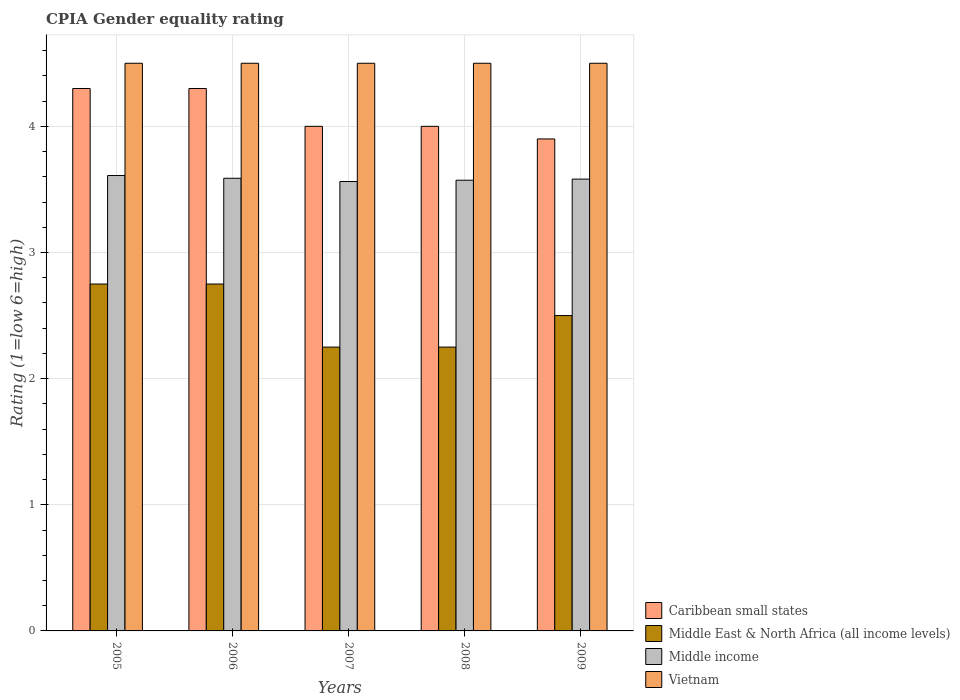How many different coloured bars are there?
Make the answer very short. 4. How many groups of bars are there?
Make the answer very short. 5. Are the number of bars on each tick of the X-axis equal?
Provide a short and direct response. Yes. How many bars are there on the 2nd tick from the left?
Provide a short and direct response. 4. How many bars are there on the 4th tick from the right?
Offer a very short reply. 4. What is the label of the 3rd group of bars from the left?
Offer a terse response. 2007. What is the CPIA rating in Caribbean small states in 2005?
Offer a very short reply. 4.3. Across all years, what is the maximum CPIA rating in Middle income?
Keep it short and to the point. 3.61. Across all years, what is the minimum CPIA rating in Middle East & North Africa (all income levels)?
Keep it short and to the point. 2.25. In which year was the CPIA rating in Vietnam maximum?
Your answer should be compact. 2005. In which year was the CPIA rating in Vietnam minimum?
Your answer should be very brief. 2005. What is the difference between the CPIA rating in Caribbean small states in 2007 and that in 2009?
Your response must be concise. 0.1. What is the difference between the CPIA rating in Caribbean small states in 2005 and the CPIA rating in Middle East & North Africa (all income levels) in 2009?
Ensure brevity in your answer.  1.8. What is the average CPIA rating in Middle East & North Africa (all income levels) per year?
Offer a terse response. 2.5. In the year 2006, what is the difference between the CPIA rating in Caribbean small states and CPIA rating in Vietnam?
Provide a succinct answer. -0.2. In how many years, is the CPIA rating in Middle income greater than 0.4?
Give a very brief answer. 5. What is the ratio of the CPIA rating in Caribbean small states in 2006 to that in 2009?
Your answer should be very brief. 1.1. What is the difference between the highest and the second highest CPIA rating in Middle East & North Africa (all income levels)?
Your response must be concise. 0. What is the difference between the highest and the lowest CPIA rating in Middle income?
Ensure brevity in your answer.  0.05. Is the sum of the CPIA rating in Middle East & North Africa (all income levels) in 2005 and 2009 greater than the maximum CPIA rating in Vietnam across all years?
Your answer should be very brief. Yes. Is it the case that in every year, the sum of the CPIA rating in Middle income and CPIA rating in Vietnam is greater than the sum of CPIA rating in Caribbean small states and CPIA rating in Middle East & North Africa (all income levels)?
Offer a terse response. No. What does the 1st bar from the left in 2009 represents?
Offer a very short reply. Caribbean small states. What does the 1st bar from the right in 2009 represents?
Offer a terse response. Vietnam. How many years are there in the graph?
Offer a terse response. 5. Does the graph contain grids?
Your answer should be very brief. Yes. How are the legend labels stacked?
Offer a terse response. Vertical. What is the title of the graph?
Provide a succinct answer. CPIA Gender equality rating. What is the Rating (1=low 6=high) of Middle East & North Africa (all income levels) in 2005?
Offer a very short reply. 2.75. What is the Rating (1=low 6=high) in Middle income in 2005?
Provide a succinct answer. 3.61. What is the Rating (1=low 6=high) in Middle East & North Africa (all income levels) in 2006?
Make the answer very short. 2.75. What is the Rating (1=low 6=high) of Middle income in 2006?
Ensure brevity in your answer.  3.59. What is the Rating (1=low 6=high) of Caribbean small states in 2007?
Provide a short and direct response. 4. What is the Rating (1=low 6=high) of Middle East & North Africa (all income levels) in 2007?
Your response must be concise. 2.25. What is the Rating (1=low 6=high) in Middle income in 2007?
Make the answer very short. 3.56. What is the Rating (1=low 6=high) in Vietnam in 2007?
Your answer should be compact. 4.5. What is the Rating (1=low 6=high) of Middle East & North Africa (all income levels) in 2008?
Ensure brevity in your answer.  2.25. What is the Rating (1=low 6=high) in Middle income in 2008?
Provide a succinct answer. 3.57. What is the Rating (1=low 6=high) in Vietnam in 2008?
Your answer should be compact. 4.5. What is the Rating (1=low 6=high) of Middle income in 2009?
Provide a short and direct response. 3.58. Across all years, what is the maximum Rating (1=low 6=high) of Caribbean small states?
Give a very brief answer. 4.3. Across all years, what is the maximum Rating (1=low 6=high) in Middle East & North Africa (all income levels)?
Provide a succinct answer. 2.75. Across all years, what is the maximum Rating (1=low 6=high) in Middle income?
Your answer should be compact. 3.61. Across all years, what is the maximum Rating (1=low 6=high) in Vietnam?
Your answer should be compact. 4.5. Across all years, what is the minimum Rating (1=low 6=high) of Caribbean small states?
Provide a short and direct response. 3.9. Across all years, what is the minimum Rating (1=low 6=high) of Middle East & North Africa (all income levels)?
Your answer should be very brief. 2.25. Across all years, what is the minimum Rating (1=low 6=high) of Middle income?
Your response must be concise. 3.56. Across all years, what is the minimum Rating (1=low 6=high) of Vietnam?
Make the answer very short. 4.5. What is the total Rating (1=low 6=high) in Caribbean small states in the graph?
Provide a succinct answer. 20.5. What is the total Rating (1=low 6=high) in Middle East & North Africa (all income levels) in the graph?
Your answer should be very brief. 12.5. What is the total Rating (1=low 6=high) in Middle income in the graph?
Keep it short and to the point. 17.92. What is the total Rating (1=low 6=high) in Vietnam in the graph?
Offer a very short reply. 22.5. What is the difference between the Rating (1=low 6=high) in Caribbean small states in 2005 and that in 2006?
Ensure brevity in your answer.  0. What is the difference between the Rating (1=low 6=high) of Middle East & North Africa (all income levels) in 2005 and that in 2006?
Offer a very short reply. 0. What is the difference between the Rating (1=low 6=high) in Middle income in 2005 and that in 2006?
Give a very brief answer. 0.02. What is the difference between the Rating (1=low 6=high) of Vietnam in 2005 and that in 2006?
Provide a succinct answer. 0. What is the difference between the Rating (1=low 6=high) of Middle income in 2005 and that in 2007?
Make the answer very short. 0.05. What is the difference between the Rating (1=low 6=high) in Middle East & North Africa (all income levels) in 2005 and that in 2008?
Keep it short and to the point. 0.5. What is the difference between the Rating (1=low 6=high) in Middle income in 2005 and that in 2008?
Provide a succinct answer. 0.04. What is the difference between the Rating (1=low 6=high) of Middle income in 2005 and that in 2009?
Give a very brief answer. 0.03. What is the difference between the Rating (1=low 6=high) of Caribbean small states in 2006 and that in 2007?
Your answer should be compact. 0.3. What is the difference between the Rating (1=low 6=high) of Middle East & North Africa (all income levels) in 2006 and that in 2007?
Offer a very short reply. 0.5. What is the difference between the Rating (1=low 6=high) in Middle income in 2006 and that in 2007?
Keep it short and to the point. 0.03. What is the difference between the Rating (1=low 6=high) in Caribbean small states in 2006 and that in 2008?
Your response must be concise. 0.3. What is the difference between the Rating (1=low 6=high) of Middle East & North Africa (all income levels) in 2006 and that in 2008?
Your response must be concise. 0.5. What is the difference between the Rating (1=low 6=high) in Middle income in 2006 and that in 2008?
Your response must be concise. 0.02. What is the difference between the Rating (1=low 6=high) of Caribbean small states in 2006 and that in 2009?
Ensure brevity in your answer.  0.4. What is the difference between the Rating (1=low 6=high) of Middle East & North Africa (all income levels) in 2006 and that in 2009?
Provide a succinct answer. 0.25. What is the difference between the Rating (1=low 6=high) in Middle income in 2006 and that in 2009?
Make the answer very short. 0.01. What is the difference between the Rating (1=low 6=high) in Caribbean small states in 2007 and that in 2008?
Offer a very short reply. 0. What is the difference between the Rating (1=low 6=high) of Middle income in 2007 and that in 2008?
Keep it short and to the point. -0.01. What is the difference between the Rating (1=low 6=high) in Vietnam in 2007 and that in 2008?
Give a very brief answer. 0. What is the difference between the Rating (1=low 6=high) in Middle East & North Africa (all income levels) in 2007 and that in 2009?
Provide a short and direct response. -0.25. What is the difference between the Rating (1=low 6=high) in Middle income in 2007 and that in 2009?
Offer a very short reply. -0.02. What is the difference between the Rating (1=low 6=high) of Vietnam in 2007 and that in 2009?
Give a very brief answer. 0. What is the difference between the Rating (1=low 6=high) in Caribbean small states in 2008 and that in 2009?
Your response must be concise. 0.1. What is the difference between the Rating (1=low 6=high) of Middle income in 2008 and that in 2009?
Keep it short and to the point. -0.01. What is the difference between the Rating (1=low 6=high) of Caribbean small states in 2005 and the Rating (1=low 6=high) of Middle East & North Africa (all income levels) in 2006?
Ensure brevity in your answer.  1.55. What is the difference between the Rating (1=low 6=high) of Caribbean small states in 2005 and the Rating (1=low 6=high) of Middle income in 2006?
Offer a very short reply. 0.71. What is the difference between the Rating (1=low 6=high) of Caribbean small states in 2005 and the Rating (1=low 6=high) of Vietnam in 2006?
Give a very brief answer. -0.2. What is the difference between the Rating (1=low 6=high) in Middle East & North Africa (all income levels) in 2005 and the Rating (1=low 6=high) in Middle income in 2006?
Offer a terse response. -0.84. What is the difference between the Rating (1=low 6=high) in Middle East & North Africa (all income levels) in 2005 and the Rating (1=low 6=high) in Vietnam in 2006?
Your answer should be compact. -1.75. What is the difference between the Rating (1=low 6=high) of Middle income in 2005 and the Rating (1=low 6=high) of Vietnam in 2006?
Make the answer very short. -0.89. What is the difference between the Rating (1=low 6=high) in Caribbean small states in 2005 and the Rating (1=low 6=high) in Middle East & North Africa (all income levels) in 2007?
Offer a very short reply. 2.05. What is the difference between the Rating (1=low 6=high) of Caribbean small states in 2005 and the Rating (1=low 6=high) of Middle income in 2007?
Your answer should be compact. 0.74. What is the difference between the Rating (1=low 6=high) in Middle East & North Africa (all income levels) in 2005 and the Rating (1=low 6=high) in Middle income in 2007?
Give a very brief answer. -0.81. What is the difference between the Rating (1=low 6=high) of Middle East & North Africa (all income levels) in 2005 and the Rating (1=low 6=high) of Vietnam in 2007?
Provide a short and direct response. -1.75. What is the difference between the Rating (1=low 6=high) in Middle income in 2005 and the Rating (1=low 6=high) in Vietnam in 2007?
Provide a short and direct response. -0.89. What is the difference between the Rating (1=low 6=high) in Caribbean small states in 2005 and the Rating (1=low 6=high) in Middle East & North Africa (all income levels) in 2008?
Offer a very short reply. 2.05. What is the difference between the Rating (1=low 6=high) of Caribbean small states in 2005 and the Rating (1=low 6=high) of Middle income in 2008?
Provide a succinct answer. 0.73. What is the difference between the Rating (1=low 6=high) in Middle East & North Africa (all income levels) in 2005 and the Rating (1=low 6=high) in Middle income in 2008?
Give a very brief answer. -0.82. What is the difference between the Rating (1=low 6=high) of Middle East & North Africa (all income levels) in 2005 and the Rating (1=low 6=high) of Vietnam in 2008?
Provide a short and direct response. -1.75. What is the difference between the Rating (1=low 6=high) in Middle income in 2005 and the Rating (1=low 6=high) in Vietnam in 2008?
Your response must be concise. -0.89. What is the difference between the Rating (1=low 6=high) of Caribbean small states in 2005 and the Rating (1=low 6=high) of Middle East & North Africa (all income levels) in 2009?
Your answer should be very brief. 1.8. What is the difference between the Rating (1=low 6=high) in Caribbean small states in 2005 and the Rating (1=low 6=high) in Middle income in 2009?
Your response must be concise. 0.72. What is the difference between the Rating (1=low 6=high) in Caribbean small states in 2005 and the Rating (1=low 6=high) in Vietnam in 2009?
Offer a terse response. -0.2. What is the difference between the Rating (1=low 6=high) of Middle East & North Africa (all income levels) in 2005 and the Rating (1=low 6=high) of Middle income in 2009?
Your response must be concise. -0.83. What is the difference between the Rating (1=low 6=high) in Middle East & North Africa (all income levels) in 2005 and the Rating (1=low 6=high) in Vietnam in 2009?
Your answer should be very brief. -1.75. What is the difference between the Rating (1=low 6=high) in Middle income in 2005 and the Rating (1=low 6=high) in Vietnam in 2009?
Your answer should be very brief. -0.89. What is the difference between the Rating (1=low 6=high) in Caribbean small states in 2006 and the Rating (1=low 6=high) in Middle East & North Africa (all income levels) in 2007?
Keep it short and to the point. 2.05. What is the difference between the Rating (1=low 6=high) in Caribbean small states in 2006 and the Rating (1=low 6=high) in Middle income in 2007?
Your answer should be compact. 0.74. What is the difference between the Rating (1=low 6=high) in Caribbean small states in 2006 and the Rating (1=low 6=high) in Vietnam in 2007?
Offer a very short reply. -0.2. What is the difference between the Rating (1=low 6=high) in Middle East & North Africa (all income levels) in 2006 and the Rating (1=low 6=high) in Middle income in 2007?
Your answer should be very brief. -0.81. What is the difference between the Rating (1=low 6=high) of Middle East & North Africa (all income levels) in 2006 and the Rating (1=low 6=high) of Vietnam in 2007?
Make the answer very short. -1.75. What is the difference between the Rating (1=low 6=high) of Middle income in 2006 and the Rating (1=low 6=high) of Vietnam in 2007?
Ensure brevity in your answer.  -0.91. What is the difference between the Rating (1=low 6=high) of Caribbean small states in 2006 and the Rating (1=low 6=high) of Middle East & North Africa (all income levels) in 2008?
Keep it short and to the point. 2.05. What is the difference between the Rating (1=low 6=high) in Caribbean small states in 2006 and the Rating (1=low 6=high) in Middle income in 2008?
Make the answer very short. 0.73. What is the difference between the Rating (1=low 6=high) of Caribbean small states in 2006 and the Rating (1=low 6=high) of Vietnam in 2008?
Provide a short and direct response. -0.2. What is the difference between the Rating (1=low 6=high) in Middle East & North Africa (all income levels) in 2006 and the Rating (1=low 6=high) in Middle income in 2008?
Keep it short and to the point. -0.82. What is the difference between the Rating (1=low 6=high) in Middle East & North Africa (all income levels) in 2006 and the Rating (1=low 6=high) in Vietnam in 2008?
Provide a succinct answer. -1.75. What is the difference between the Rating (1=low 6=high) in Middle income in 2006 and the Rating (1=low 6=high) in Vietnam in 2008?
Make the answer very short. -0.91. What is the difference between the Rating (1=low 6=high) of Caribbean small states in 2006 and the Rating (1=low 6=high) of Middle income in 2009?
Make the answer very short. 0.72. What is the difference between the Rating (1=low 6=high) in Middle East & North Africa (all income levels) in 2006 and the Rating (1=low 6=high) in Middle income in 2009?
Your answer should be compact. -0.83. What is the difference between the Rating (1=low 6=high) of Middle East & North Africa (all income levels) in 2006 and the Rating (1=low 6=high) of Vietnam in 2009?
Offer a terse response. -1.75. What is the difference between the Rating (1=low 6=high) in Middle income in 2006 and the Rating (1=low 6=high) in Vietnam in 2009?
Ensure brevity in your answer.  -0.91. What is the difference between the Rating (1=low 6=high) in Caribbean small states in 2007 and the Rating (1=low 6=high) in Middle income in 2008?
Your answer should be compact. 0.43. What is the difference between the Rating (1=low 6=high) in Middle East & North Africa (all income levels) in 2007 and the Rating (1=low 6=high) in Middle income in 2008?
Give a very brief answer. -1.32. What is the difference between the Rating (1=low 6=high) of Middle East & North Africa (all income levels) in 2007 and the Rating (1=low 6=high) of Vietnam in 2008?
Offer a terse response. -2.25. What is the difference between the Rating (1=low 6=high) in Middle income in 2007 and the Rating (1=low 6=high) in Vietnam in 2008?
Give a very brief answer. -0.94. What is the difference between the Rating (1=low 6=high) of Caribbean small states in 2007 and the Rating (1=low 6=high) of Middle income in 2009?
Ensure brevity in your answer.  0.42. What is the difference between the Rating (1=low 6=high) in Middle East & North Africa (all income levels) in 2007 and the Rating (1=low 6=high) in Middle income in 2009?
Give a very brief answer. -1.33. What is the difference between the Rating (1=low 6=high) in Middle East & North Africa (all income levels) in 2007 and the Rating (1=low 6=high) in Vietnam in 2009?
Provide a succinct answer. -2.25. What is the difference between the Rating (1=low 6=high) of Middle income in 2007 and the Rating (1=low 6=high) of Vietnam in 2009?
Provide a succinct answer. -0.94. What is the difference between the Rating (1=low 6=high) of Caribbean small states in 2008 and the Rating (1=low 6=high) of Middle East & North Africa (all income levels) in 2009?
Keep it short and to the point. 1.5. What is the difference between the Rating (1=low 6=high) in Caribbean small states in 2008 and the Rating (1=low 6=high) in Middle income in 2009?
Keep it short and to the point. 0.42. What is the difference between the Rating (1=low 6=high) in Caribbean small states in 2008 and the Rating (1=low 6=high) in Vietnam in 2009?
Your response must be concise. -0.5. What is the difference between the Rating (1=low 6=high) in Middle East & North Africa (all income levels) in 2008 and the Rating (1=low 6=high) in Middle income in 2009?
Your answer should be compact. -1.33. What is the difference between the Rating (1=low 6=high) in Middle East & North Africa (all income levels) in 2008 and the Rating (1=low 6=high) in Vietnam in 2009?
Your answer should be very brief. -2.25. What is the difference between the Rating (1=low 6=high) of Middle income in 2008 and the Rating (1=low 6=high) of Vietnam in 2009?
Make the answer very short. -0.93. What is the average Rating (1=low 6=high) of Caribbean small states per year?
Your response must be concise. 4.1. What is the average Rating (1=low 6=high) of Middle East & North Africa (all income levels) per year?
Offer a very short reply. 2.5. What is the average Rating (1=low 6=high) of Middle income per year?
Make the answer very short. 3.58. What is the average Rating (1=low 6=high) in Vietnam per year?
Your response must be concise. 4.5. In the year 2005, what is the difference between the Rating (1=low 6=high) in Caribbean small states and Rating (1=low 6=high) in Middle East & North Africa (all income levels)?
Make the answer very short. 1.55. In the year 2005, what is the difference between the Rating (1=low 6=high) of Caribbean small states and Rating (1=low 6=high) of Middle income?
Ensure brevity in your answer.  0.69. In the year 2005, what is the difference between the Rating (1=low 6=high) of Caribbean small states and Rating (1=low 6=high) of Vietnam?
Provide a succinct answer. -0.2. In the year 2005, what is the difference between the Rating (1=low 6=high) in Middle East & North Africa (all income levels) and Rating (1=low 6=high) in Middle income?
Provide a short and direct response. -0.86. In the year 2005, what is the difference between the Rating (1=low 6=high) in Middle East & North Africa (all income levels) and Rating (1=low 6=high) in Vietnam?
Make the answer very short. -1.75. In the year 2005, what is the difference between the Rating (1=low 6=high) of Middle income and Rating (1=low 6=high) of Vietnam?
Your answer should be very brief. -0.89. In the year 2006, what is the difference between the Rating (1=low 6=high) in Caribbean small states and Rating (1=low 6=high) in Middle East & North Africa (all income levels)?
Your response must be concise. 1.55. In the year 2006, what is the difference between the Rating (1=low 6=high) of Caribbean small states and Rating (1=low 6=high) of Middle income?
Your response must be concise. 0.71. In the year 2006, what is the difference between the Rating (1=low 6=high) in Middle East & North Africa (all income levels) and Rating (1=low 6=high) in Middle income?
Your answer should be compact. -0.84. In the year 2006, what is the difference between the Rating (1=low 6=high) of Middle East & North Africa (all income levels) and Rating (1=low 6=high) of Vietnam?
Give a very brief answer. -1.75. In the year 2006, what is the difference between the Rating (1=low 6=high) of Middle income and Rating (1=low 6=high) of Vietnam?
Ensure brevity in your answer.  -0.91. In the year 2007, what is the difference between the Rating (1=low 6=high) in Caribbean small states and Rating (1=low 6=high) in Middle income?
Provide a succinct answer. 0.44. In the year 2007, what is the difference between the Rating (1=low 6=high) in Caribbean small states and Rating (1=low 6=high) in Vietnam?
Make the answer very short. -0.5. In the year 2007, what is the difference between the Rating (1=low 6=high) of Middle East & North Africa (all income levels) and Rating (1=low 6=high) of Middle income?
Your answer should be compact. -1.31. In the year 2007, what is the difference between the Rating (1=low 6=high) of Middle East & North Africa (all income levels) and Rating (1=low 6=high) of Vietnam?
Offer a very short reply. -2.25. In the year 2007, what is the difference between the Rating (1=low 6=high) in Middle income and Rating (1=low 6=high) in Vietnam?
Ensure brevity in your answer.  -0.94. In the year 2008, what is the difference between the Rating (1=low 6=high) in Caribbean small states and Rating (1=low 6=high) in Middle East & North Africa (all income levels)?
Your answer should be very brief. 1.75. In the year 2008, what is the difference between the Rating (1=low 6=high) of Caribbean small states and Rating (1=low 6=high) of Middle income?
Provide a short and direct response. 0.43. In the year 2008, what is the difference between the Rating (1=low 6=high) in Middle East & North Africa (all income levels) and Rating (1=low 6=high) in Middle income?
Your answer should be very brief. -1.32. In the year 2008, what is the difference between the Rating (1=low 6=high) of Middle East & North Africa (all income levels) and Rating (1=low 6=high) of Vietnam?
Your response must be concise. -2.25. In the year 2008, what is the difference between the Rating (1=low 6=high) of Middle income and Rating (1=low 6=high) of Vietnam?
Provide a succinct answer. -0.93. In the year 2009, what is the difference between the Rating (1=low 6=high) of Caribbean small states and Rating (1=low 6=high) of Middle income?
Ensure brevity in your answer.  0.32. In the year 2009, what is the difference between the Rating (1=low 6=high) in Caribbean small states and Rating (1=low 6=high) in Vietnam?
Make the answer very short. -0.6. In the year 2009, what is the difference between the Rating (1=low 6=high) of Middle East & North Africa (all income levels) and Rating (1=low 6=high) of Middle income?
Make the answer very short. -1.08. In the year 2009, what is the difference between the Rating (1=low 6=high) in Middle East & North Africa (all income levels) and Rating (1=low 6=high) in Vietnam?
Offer a terse response. -2. In the year 2009, what is the difference between the Rating (1=low 6=high) in Middle income and Rating (1=low 6=high) in Vietnam?
Offer a terse response. -0.92. What is the ratio of the Rating (1=low 6=high) of Caribbean small states in 2005 to that in 2006?
Keep it short and to the point. 1. What is the ratio of the Rating (1=low 6=high) in Middle East & North Africa (all income levels) in 2005 to that in 2006?
Your answer should be compact. 1. What is the ratio of the Rating (1=low 6=high) in Middle income in 2005 to that in 2006?
Provide a short and direct response. 1.01. What is the ratio of the Rating (1=low 6=high) in Caribbean small states in 2005 to that in 2007?
Your response must be concise. 1.07. What is the ratio of the Rating (1=low 6=high) in Middle East & North Africa (all income levels) in 2005 to that in 2007?
Provide a short and direct response. 1.22. What is the ratio of the Rating (1=low 6=high) in Middle income in 2005 to that in 2007?
Give a very brief answer. 1.01. What is the ratio of the Rating (1=low 6=high) of Caribbean small states in 2005 to that in 2008?
Provide a succinct answer. 1.07. What is the ratio of the Rating (1=low 6=high) in Middle East & North Africa (all income levels) in 2005 to that in 2008?
Give a very brief answer. 1.22. What is the ratio of the Rating (1=low 6=high) in Middle income in 2005 to that in 2008?
Offer a terse response. 1.01. What is the ratio of the Rating (1=low 6=high) in Caribbean small states in 2005 to that in 2009?
Offer a terse response. 1.1. What is the ratio of the Rating (1=low 6=high) of Middle income in 2005 to that in 2009?
Keep it short and to the point. 1.01. What is the ratio of the Rating (1=low 6=high) in Caribbean small states in 2006 to that in 2007?
Provide a succinct answer. 1.07. What is the ratio of the Rating (1=low 6=high) of Middle East & North Africa (all income levels) in 2006 to that in 2007?
Your response must be concise. 1.22. What is the ratio of the Rating (1=low 6=high) in Vietnam in 2006 to that in 2007?
Offer a very short reply. 1. What is the ratio of the Rating (1=low 6=high) of Caribbean small states in 2006 to that in 2008?
Provide a short and direct response. 1.07. What is the ratio of the Rating (1=low 6=high) in Middle East & North Africa (all income levels) in 2006 to that in 2008?
Give a very brief answer. 1.22. What is the ratio of the Rating (1=low 6=high) in Middle income in 2006 to that in 2008?
Offer a very short reply. 1. What is the ratio of the Rating (1=low 6=high) of Vietnam in 2006 to that in 2008?
Provide a succinct answer. 1. What is the ratio of the Rating (1=low 6=high) of Caribbean small states in 2006 to that in 2009?
Your answer should be compact. 1.1. What is the ratio of the Rating (1=low 6=high) in Middle income in 2006 to that in 2009?
Your answer should be compact. 1. What is the ratio of the Rating (1=low 6=high) of Vietnam in 2006 to that in 2009?
Make the answer very short. 1. What is the ratio of the Rating (1=low 6=high) of Middle East & North Africa (all income levels) in 2007 to that in 2008?
Offer a very short reply. 1. What is the ratio of the Rating (1=low 6=high) in Caribbean small states in 2007 to that in 2009?
Ensure brevity in your answer.  1.03. What is the ratio of the Rating (1=low 6=high) of Caribbean small states in 2008 to that in 2009?
Give a very brief answer. 1.03. What is the ratio of the Rating (1=low 6=high) in Vietnam in 2008 to that in 2009?
Ensure brevity in your answer.  1. What is the difference between the highest and the second highest Rating (1=low 6=high) in Caribbean small states?
Provide a succinct answer. 0. What is the difference between the highest and the second highest Rating (1=low 6=high) of Middle income?
Your answer should be very brief. 0.02. What is the difference between the highest and the second highest Rating (1=low 6=high) of Vietnam?
Your response must be concise. 0. What is the difference between the highest and the lowest Rating (1=low 6=high) of Caribbean small states?
Keep it short and to the point. 0.4. What is the difference between the highest and the lowest Rating (1=low 6=high) in Middle East & North Africa (all income levels)?
Your response must be concise. 0.5. What is the difference between the highest and the lowest Rating (1=low 6=high) of Middle income?
Offer a very short reply. 0.05. 